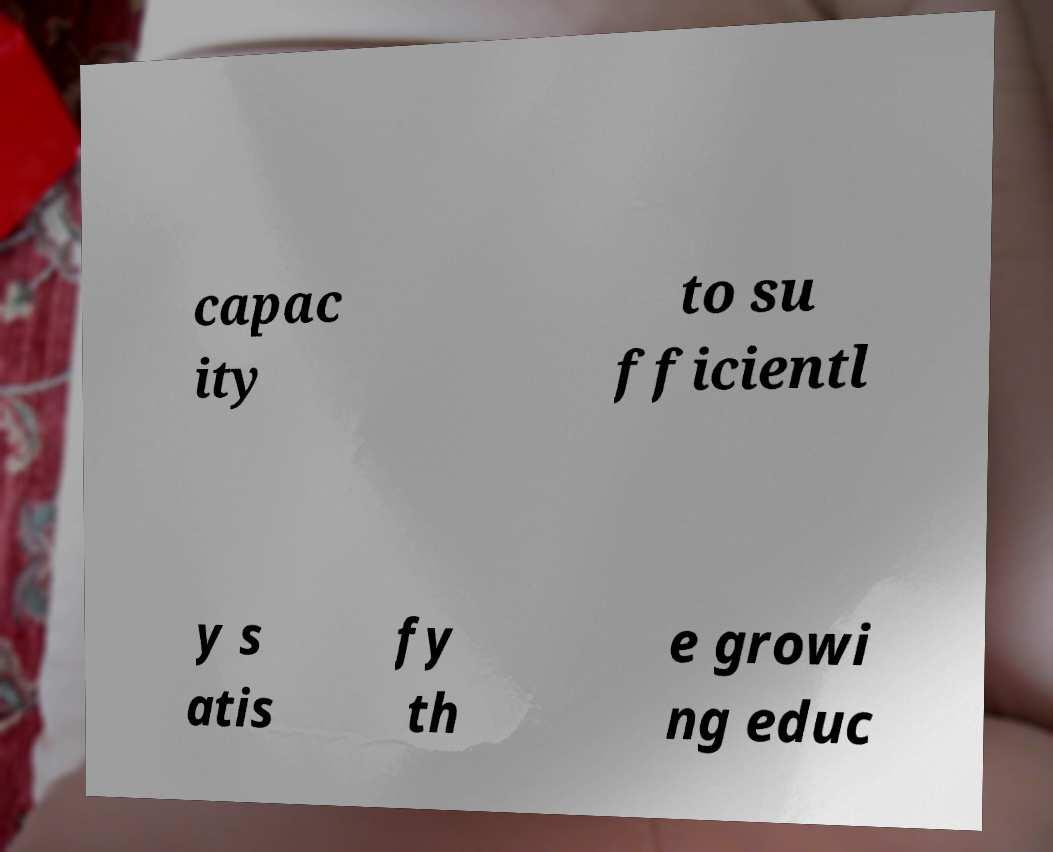What messages or text are displayed in this image? I need them in a readable, typed format. capac ity to su fficientl y s atis fy th e growi ng educ 